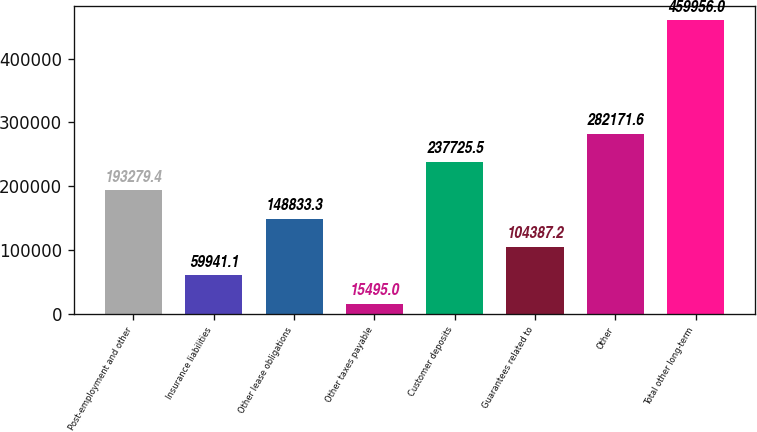<chart> <loc_0><loc_0><loc_500><loc_500><bar_chart><fcel>Post-employment and other<fcel>Insurance liabilities<fcel>Other lease obligations<fcel>Other taxes payable<fcel>Customer deposits<fcel>Guarantees related to<fcel>Other<fcel>Total other long-term<nl><fcel>193279<fcel>59941.1<fcel>148833<fcel>15495<fcel>237726<fcel>104387<fcel>282172<fcel>459956<nl></chart> 